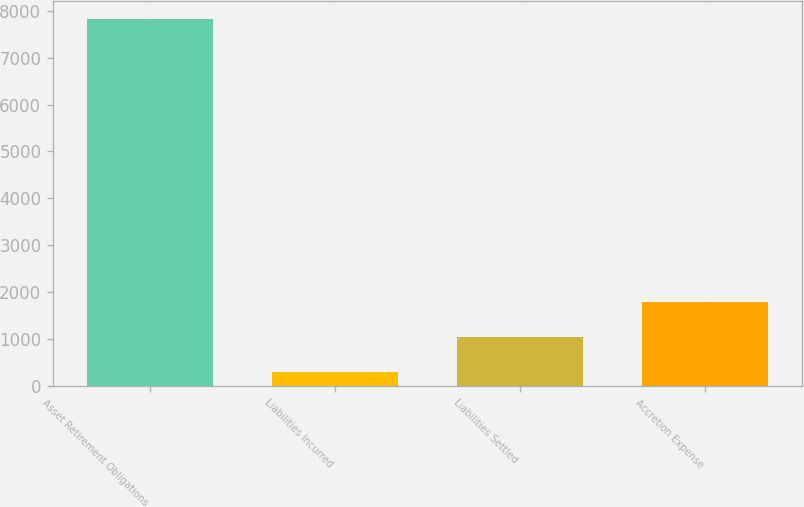Convert chart. <chart><loc_0><loc_0><loc_500><loc_500><bar_chart><fcel>Asset Retirement Obligations<fcel>Liabilities Incurred<fcel>Liabilities Settled<fcel>Accretion Expense<nl><fcel>7822.8<fcel>287<fcel>1035.8<fcel>1784.6<nl></chart> 